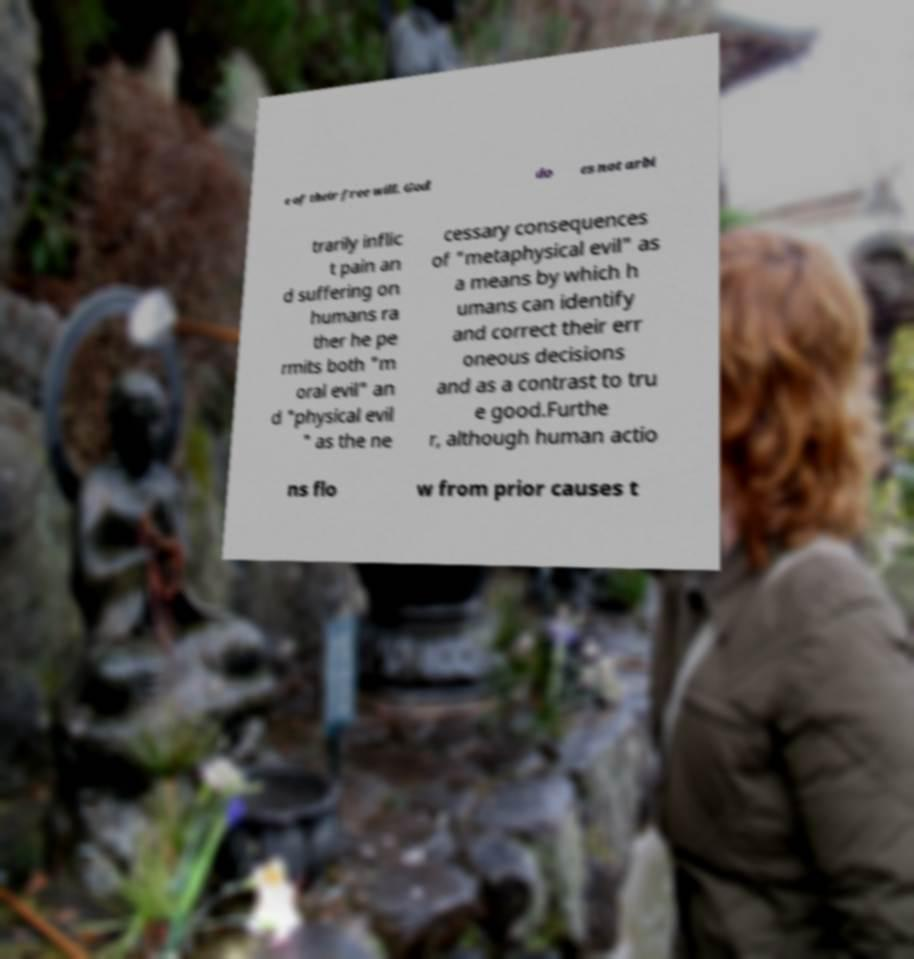Can you accurately transcribe the text from the provided image for me? e of their free will. God do es not arbi trarily inflic t pain an d suffering on humans ra ther he pe rmits both "m oral evil" an d "physical evil " as the ne cessary consequences of "metaphysical evil" as a means by which h umans can identify and correct their err oneous decisions and as a contrast to tru e good.Furthe r, although human actio ns flo w from prior causes t 